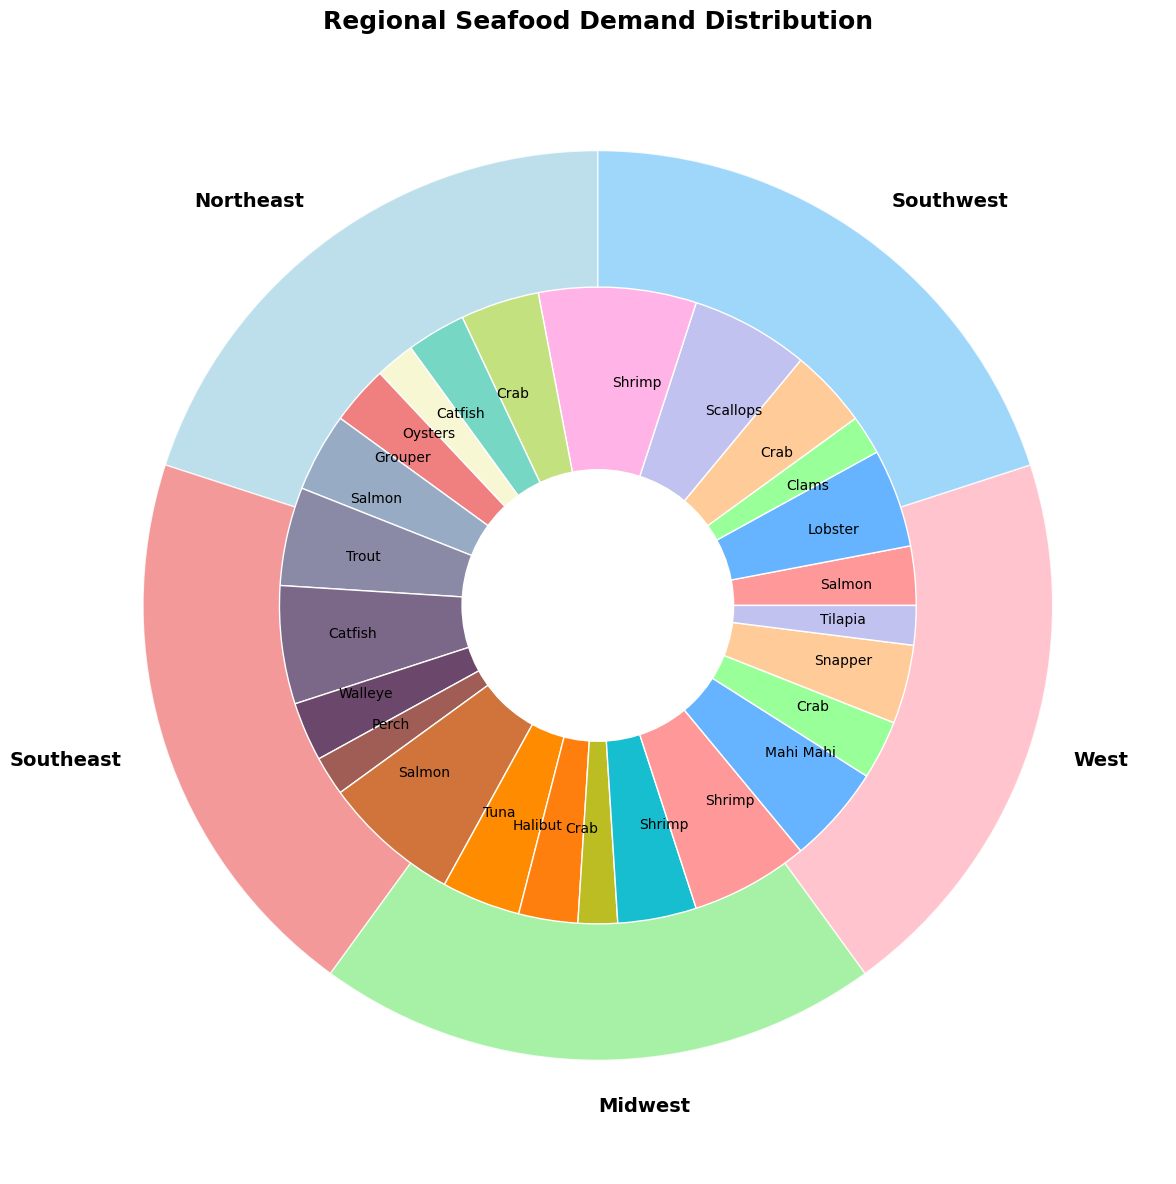What region has the highest demand for seafood? The outer pie chart segments represent different regions, and the size of each segment shows the total demand. The region with the largest segment has the highest demand.
Answer: Northeast What seafood type has the highest demand in the Southeast region? The inner pie chart segments within the Southeast region denote different seafood types, and the segment with the largest size shows the highest demand.
Answer: Shrimp Which region has the lowest demand for seafood? Look at the smallest outer pie chart segment, which represents the region with the least demand.
Answer: Midwest Compare the demand for Salmon in the Northeast and West regions. Which region has higher demand? Compare the inner pie chart segments labeled "Salmon" within the Northeast and West regions. The segment with the larger size indicates higher demand.
Answer: West What's the total demand percentage of Crab across all regions? Sum up the inner pie chart segments labeled "Crab" across all regions: 20% (Northeast) + 20% (Southeast) + 10% (West) + 15% (Southwest) = 65%.
Answer: 65% Which seafood type has the lowest demand in the Midwest region? Within the Midwest region segment of the inner pie chart, find the smallest segment, representing the seafood type with the lowest demand.
Answer: Perch Is the demand for Shrimp greater in the Southeast or Southwest region? Compare the inner pie chart segments labeled "Shrimp" within the Southeast and Southwest regions. The larger segment indicates higher demand.
Answer: Southeast What is the difference in total demand between the Northeast and Southwest regions? Subtract the total demand percentage of Southwest region from the Northeast: 100% (Northeast) - 100% (Southwest) = 0%.
Answer: 0% Which region has a more diversified seafood demand (i.e., more evenly distributed across different types)? Compare the inner pie chart segments within each region. The region where the segments are more equal in size has a more diversified demand.
Answer: Midwest 